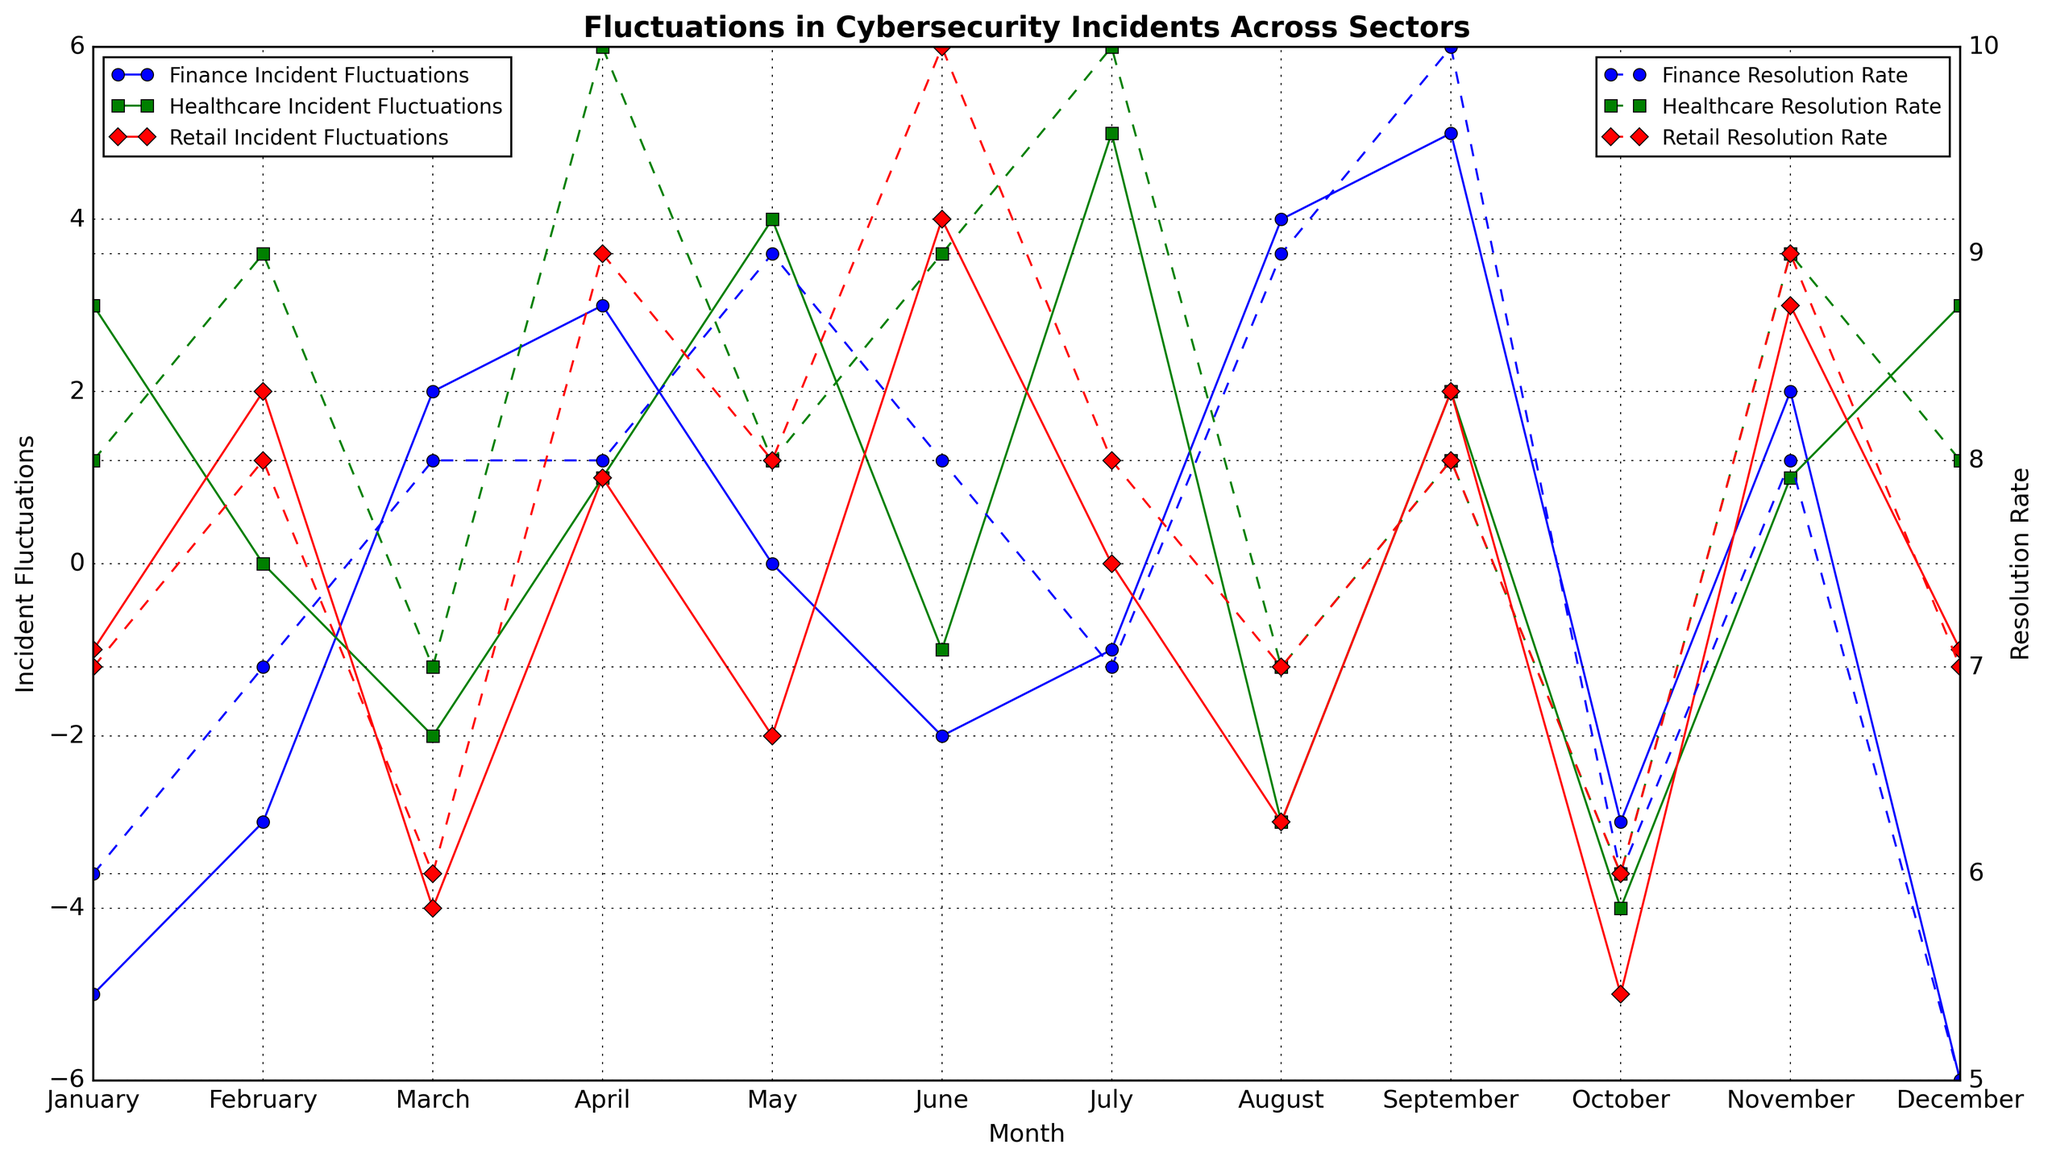What is the trend of the Incident Fluctuations for the Finance sector from January to December? By observing the line representing Finance Incident Fluctuations, we note the rising and falling points. Starting from -5 in January, with fluctuations such as 3 in April and reaching up to 5 in September, but there are also negative dips, ending at -6 in December.
Answer: The trend is variable with significant fluctuations, both positive and negative In which month does the Healthcare sector have the maximum Incident Fluctuations? To determine the maximum value within the Healthcare sector's Incident Fluctuations, identify the peak point on the green line. It shows a peak in July at a value of 5.
Answer: July How does the Resolution Rate trend for the Retail sector compare to Incident Fluctuations from June to October? Examine June to October for the Retail sector. The Incident Fluctuations go from 4 in June to -5 in October. The Resolution Rate, on the other hand, moves from 10 in June to 6 in October, indicating a decreasing trend for both metrics.
Answer: Both metrics show a decreasing trend Which sector has the most fluctuating incident values around 0 (both negative and positive) across months? Identify the sector whose Incident Fluctuations hover around 0. In this case, the Retail sector shows multiple points near 0 (e.g., January: -1, February: 2, May: -2, July: 0, and December: -1).
Answer: Retail Comparing the Incident Fluctuations of Finance and Healthcare in August, which sector has more severe fluctuations? Look at the Incident Fluctuations for both sectors in August. The Finance sector's value is 4 while Healthcare is -3. Considering absolute values, Finance has more severe fluctuations.
Answer: Finance What is the difference in Resolution Rate between Finance and Healthcare in December? For December, Finance's Resolution Rate is 5 while Healthcare's is 8. The difference is obtained by subtracting 5 from 8.
Answer: 3 Between February and March, how do Healthcare Incident Fluctuations change compared to the Finance sector? Healthcare Incident Fluctuations go from 0 to -2 (a decrease of 2). Finance changes from -3 to 2 (an increase of 5).
Answer: Healthcare decreases by 2, Finance increases by 5 What color represents the sector with a Resolution Rate of 10 in April? Look at April on the secondary y-axis for a Resolution Rate of 10. It is represented by the Healthcare sector, marked in green.
Answer: Green In which month does Retail have its lowest Incident Fluctuations, and what is the value? Follow the Retail sector's red line to its lowest point. Retail has its lowest Incident Fluctuations in October with a value of -5.
Answer: October, -5 